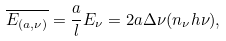Convert formula to latex. <formula><loc_0><loc_0><loc_500><loc_500>\overline { E _ { ( a , \nu ) } } = \frac { a } { l } E _ { \nu } = 2 a \Delta \nu ( n _ { \nu } h \nu ) ,</formula> 